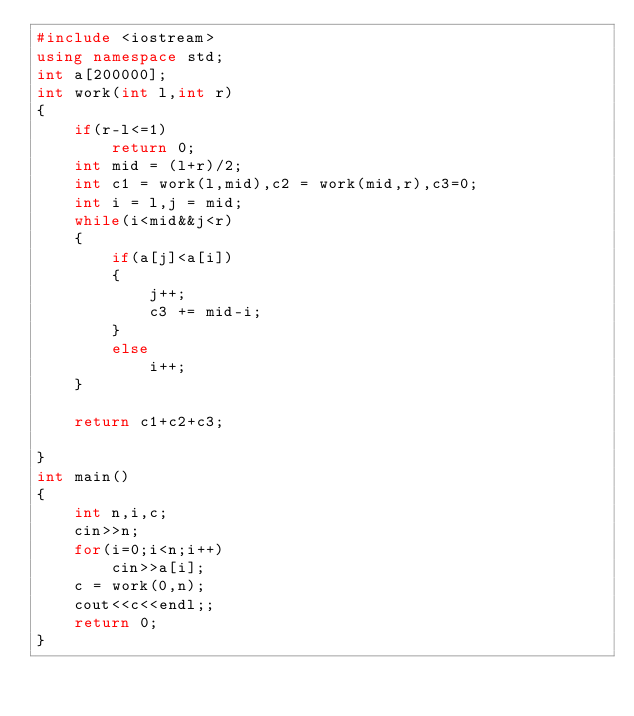Convert code to text. <code><loc_0><loc_0><loc_500><loc_500><_C++_>#include <iostream>
using namespace std;
int a[200000];
int work(int l,int r)
{
    if(r-l<=1)
        return 0;
    int mid = (l+r)/2;
    int c1 = work(l,mid),c2 = work(mid,r),c3=0;
    int i = l,j = mid;
    while(i<mid&&j<r)
    {
        if(a[j]<a[i])
        {
            j++;
            c3 += mid-i;
        }
        else
            i++;
    }

    return c1+c2+c3;

}
int main()
{
    int n,i,c;
    cin>>n;
    for(i=0;i<n;i++)
        cin>>a[i];
    c = work(0,n);
    cout<<c<<endl;;
    return 0;
}</code> 